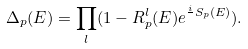Convert formula to latex. <formula><loc_0><loc_0><loc_500><loc_500>\Delta _ { p } ( E ) = \prod _ { l } ( 1 - R ^ { l } _ { p } ( E ) e ^ { \frac { i } { } S _ { p } ( E ) } ) .</formula> 